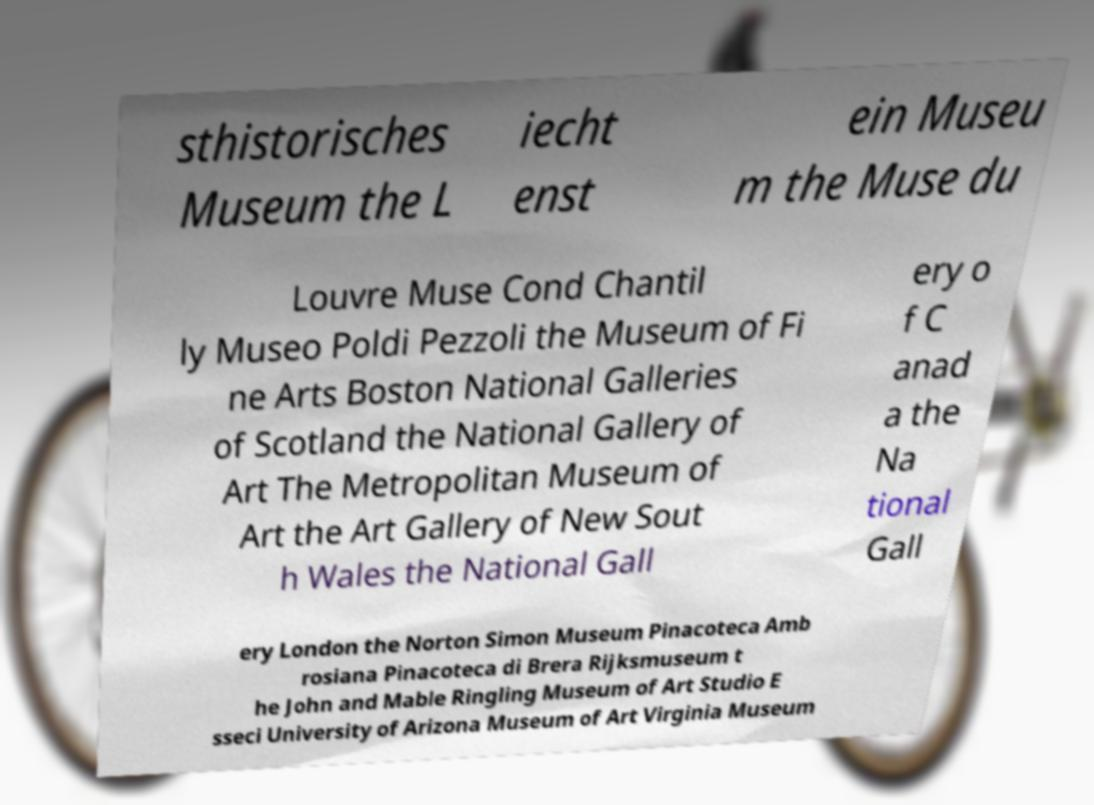I need the written content from this picture converted into text. Can you do that? sthistorisches Museum the L iecht enst ein Museu m the Muse du Louvre Muse Cond Chantil ly Museo Poldi Pezzoli the Museum of Fi ne Arts Boston National Galleries of Scotland the National Gallery of Art The Metropolitan Museum of Art the Art Gallery of New Sout h Wales the National Gall ery o f C anad a the Na tional Gall ery London the Norton Simon Museum Pinacoteca Amb rosiana Pinacoteca di Brera Rijksmuseum t he John and Mable Ringling Museum of Art Studio E sseci University of Arizona Museum of Art Virginia Museum 